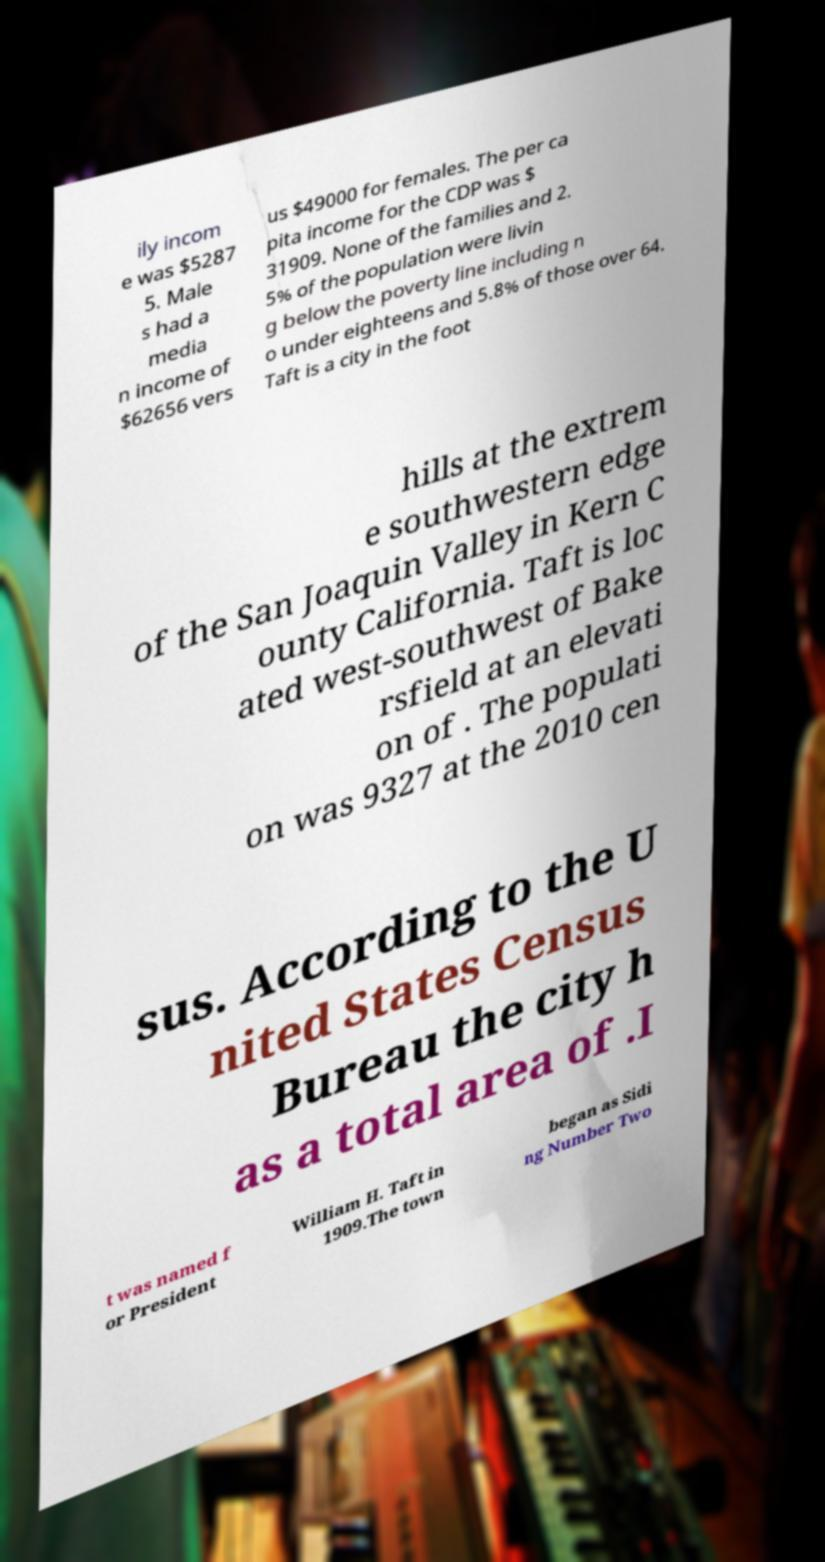Please identify and transcribe the text found in this image. ily incom e was $5287 5. Male s had a media n income of $62656 vers us $49000 for females. The per ca pita income for the CDP was $ 31909. None of the families and 2. 5% of the population were livin g below the poverty line including n o under eighteens and 5.8% of those over 64. Taft is a city in the foot hills at the extrem e southwestern edge of the San Joaquin Valley in Kern C ounty California. Taft is loc ated west-southwest of Bake rsfield at an elevati on of . The populati on was 9327 at the 2010 cen sus. According to the U nited States Census Bureau the city h as a total area of .I t was named f or President William H. Taft in 1909.The town began as Sidi ng Number Two 